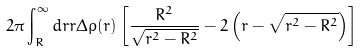<formula> <loc_0><loc_0><loc_500><loc_500>2 \pi \int _ { R } ^ { \infty } d r r \Delta \rho ( r ) \left [ \frac { R ^ { 2 } } { \sqrt { r ^ { 2 } - R ^ { 2 } } } - 2 \left ( r - \sqrt { r ^ { 2 } - R ^ { 2 } } \right ) \right ]</formula> 